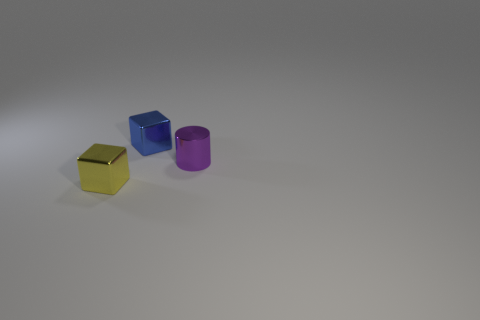Add 1 tiny blue metal cylinders. How many objects exist? 4 Subtract all cylinders. How many objects are left? 2 Add 2 large gray metal balls. How many large gray metal balls exist? 2 Subtract 0 cyan spheres. How many objects are left? 3 Subtract all tiny red metallic spheres. Subtract all cylinders. How many objects are left? 2 Add 3 cubes. How many cubes are left? 5 